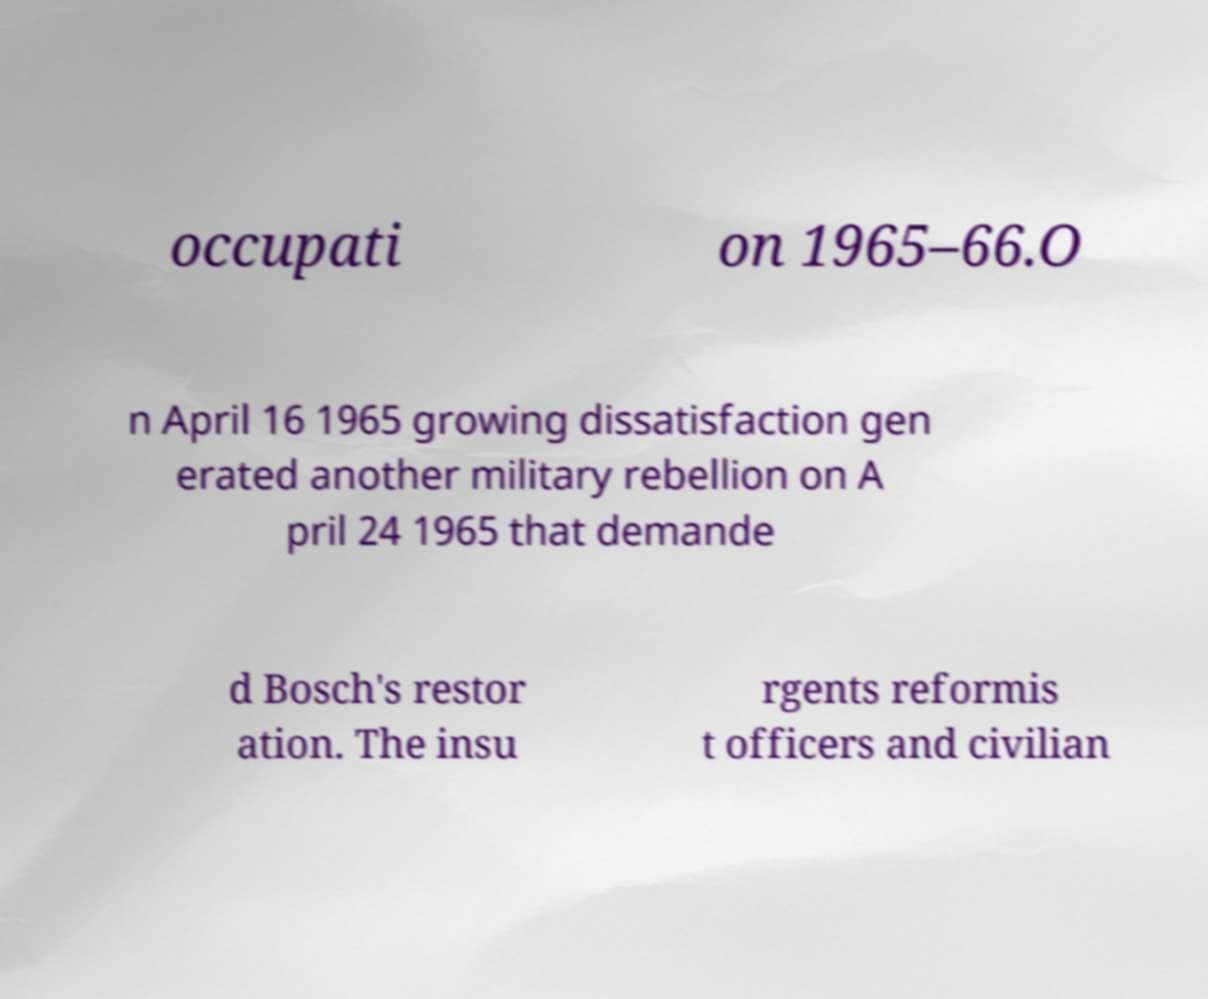For documentation purposes, I need the text within this image transcribed. Could you provide that? occupati on 1965–66.O n April 16 1965 growing dissatisfaction gen erated another military rebellion on A pril 24 1965 that demande d Bosch's restor ation. The insu rgents reformis t officers and civilian 